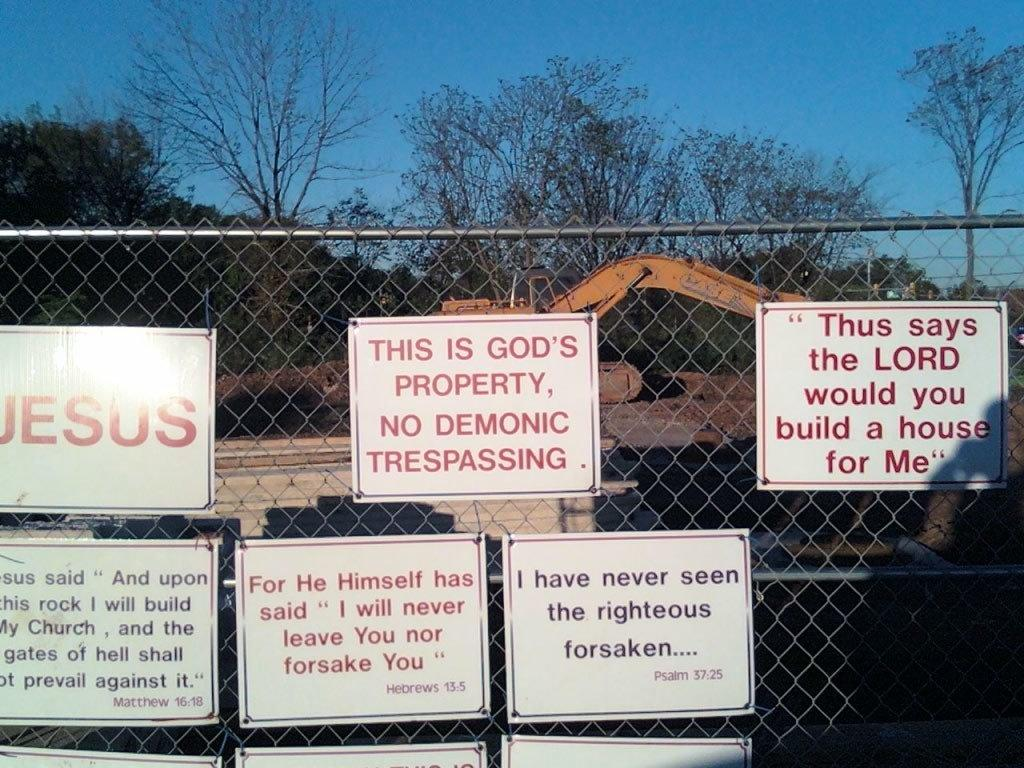Provide a one-sentence caption for the provided image. Various religions signs adorn a construction site's fence. 